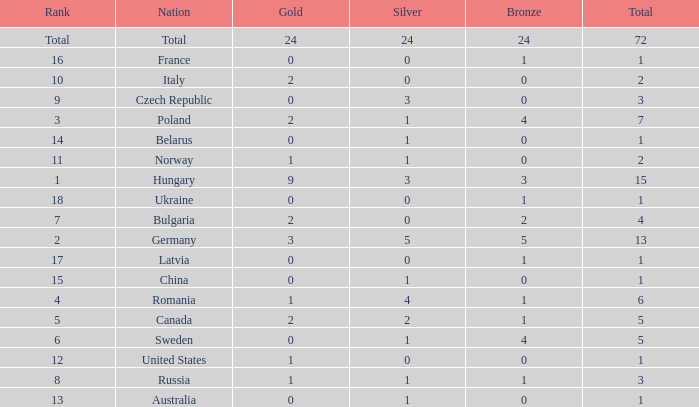What average silver has belarus as the nation, with a total less than 1? None. 